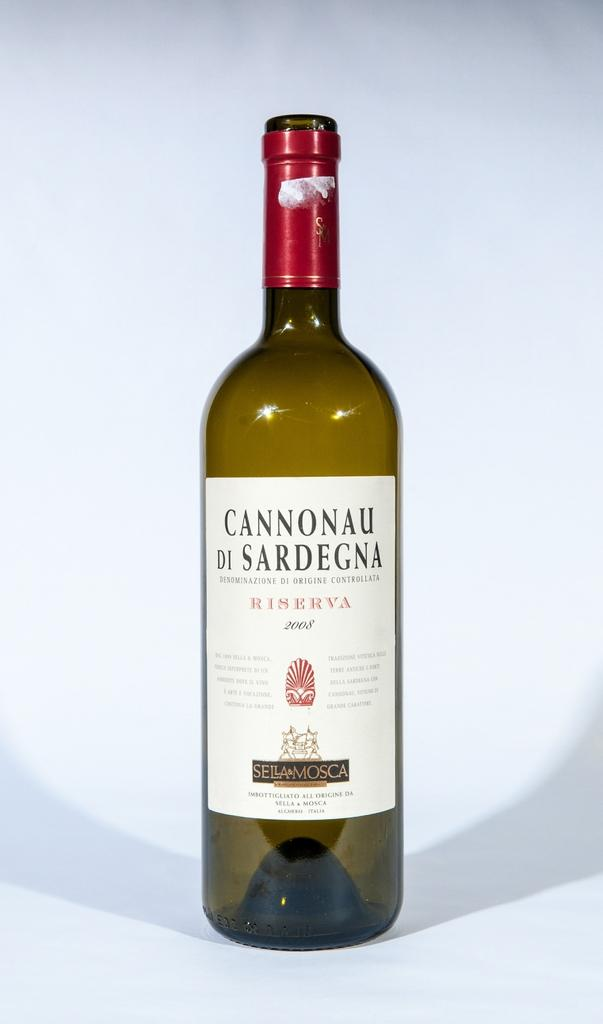<image>
Describe the image concisely. A bottle of Cannonau sits empty against a white background 